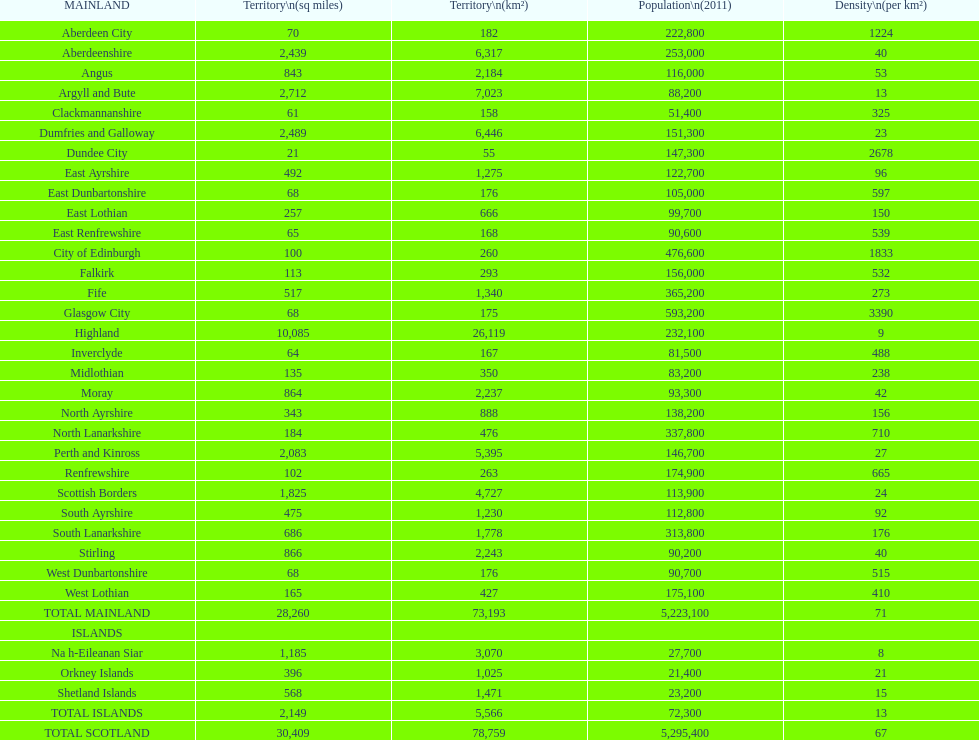Which location would be at the top of the list when arranged in ascending order of area size? Dundee City. Could you parse the entire table as a dict? {'header': ['MAINLAND', 'Territory\\n(sq miles)', 'Territory\\n(km²)', 'Population\\n(2011)', 'Density\\n(per km²)'], 'rows': [['Aberdeen City', '70', '182', '222,800', '1224'], ['Aberdeenshire', '2,439', '6,317', '253,000', '40'], ['Angus', '843', '2,184', '116,000', '53'], ['Argyll and Bute', '2,712', '7,023', '88,200', '13'], ['Clackmannanshire', '61', '158', '51,400', '325'], ['Dumfries and Galloway', '2,489', '6,446', '151,300', '23'], ['Dundee City', '21', '55', '147,300', '2678'], ['East Ayrshire', '492', '1,275', '122,700', '96'], ['East Dunbartonshire', '68', '176', '105,000', '597'], ['East Lothian', '257', '666', '99,700', '150'], ['East Renfrewshire', '65', '168', '90,600', '539'], ['City of Edinburgh', '100', '260', '476,600', '1833'], ['Falkirk', '113', '293', '156,000', '532'], ['Fife', '517', '1,340', '365,200', '273'], ['Glasgow City', '68', '175', '593,200', '3390'], ['Highland', '10,085', '26,119', '232,100', '9'], ['Inverclyde', '64', '167', '81,500', '488'], ['Midlothian', '135', '350', '83,200', '238'], ['Moray', '864', '2,237', '93,300', '42'], ['North Ayrshire', '343', '888', '138,200', '156'], ['North Lanarkshire', '184', '476', '337,800', '710'], ['Perth and Kinross', '2,083', '5,395', '146,700', '27'], ['Renfrewshire', '102', '263', '174,900', '665'], ['Scottish Borders', '1,825', '4,727', '113,900', '24'], ['South Ayrshire', '475', '1,230', '112,800', '92'], ['South Lanarkshire', '686', '1,778', '313,800', '176'], ['Stirling', '866', '2,243', '90,200', '40'], ['West Dunbartonshire', '68', '176', '90,700', '515'], ['West Lothian', '165', '427', '175,100', '410'], ['TOTAL MAINLAND', '28,260', '73,193', '5,223,100', '71'], ['ISLANDS', '', '', '', ''], ['Na h-Eileanan Siar', '1,185', '3,070', '27,700', '8'], ['Orkney Islands', '396', '1,025', '21,400', '21'], ['Shetland Islands', '568', '1,471', '23,200', '15'], ['TOTAL ISLANDS', '2,149', '5,566', '72,300', '13'], ['TOTAL SCOTLAND', '30,409', '78,759', '5,295,400', '67']]} 